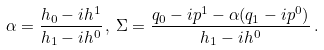<formula> <loc_0><loc_0><loc_500><loc_500>\alpha = \frac { h _ { 0 } - i h ^ { 1 } } { h _ { 1 } - i h ^ { 0 } } \, , \, \Sigma = \frac { q _ { 0 } - i p ^ { 1 } - \alpha ( q _ { 1 } - i p ^ { 0 } ) } { h _ { 1 } - i h ^ { 0 } } \, .</formula> 